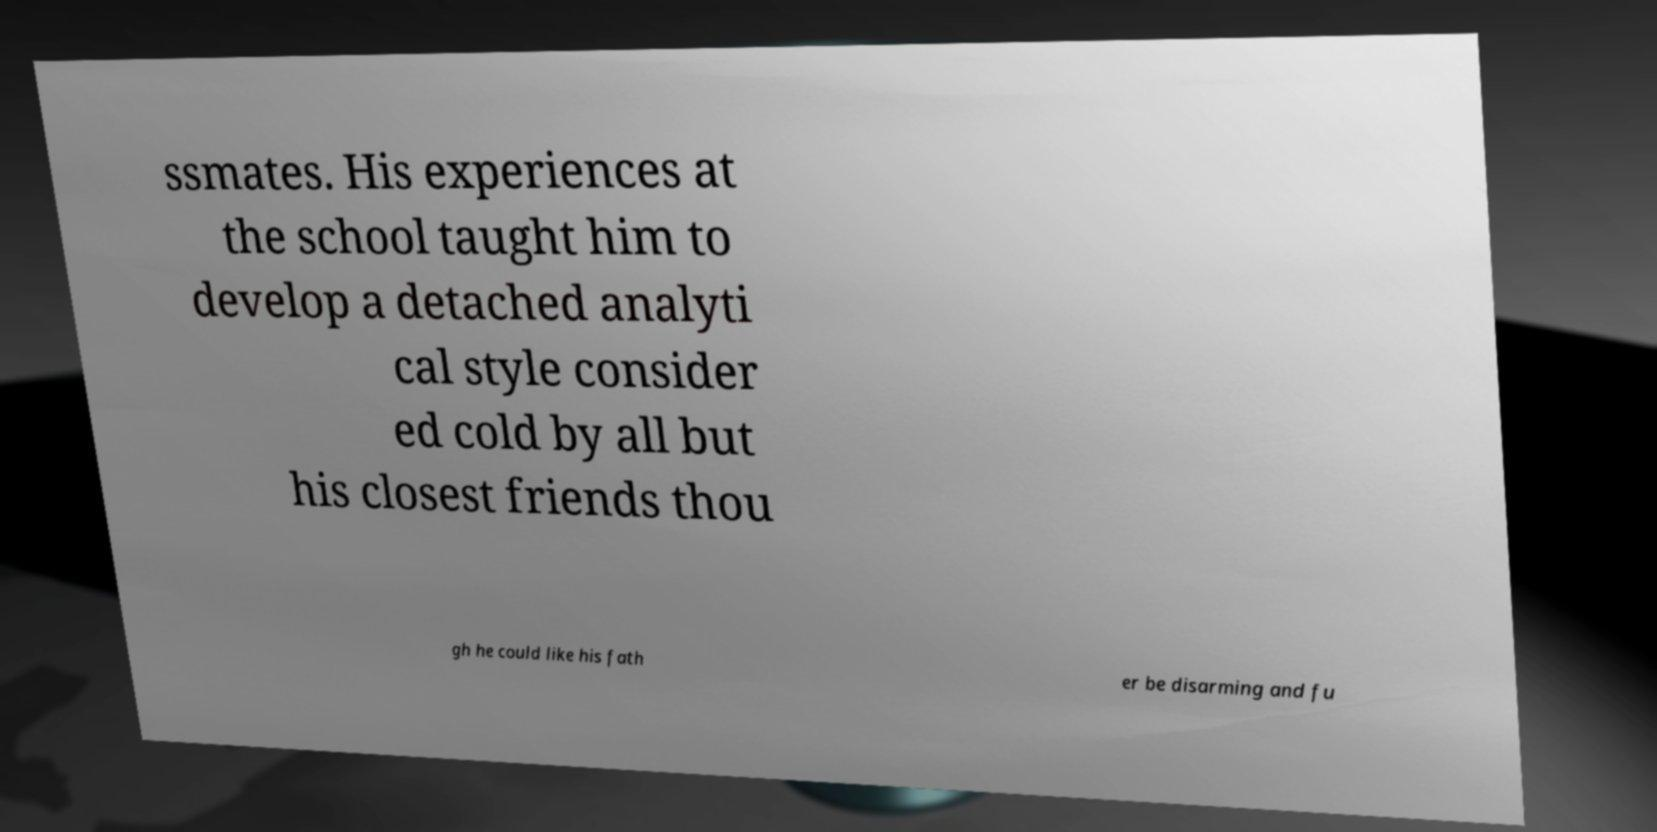Please read and relay the text visible in this image. What does it say? ssmates. His experiences at the school taught him to develop a detached analyti cal style consider ed cold by all but his closest friends thou gh he could like his fath er be disarming and fu 